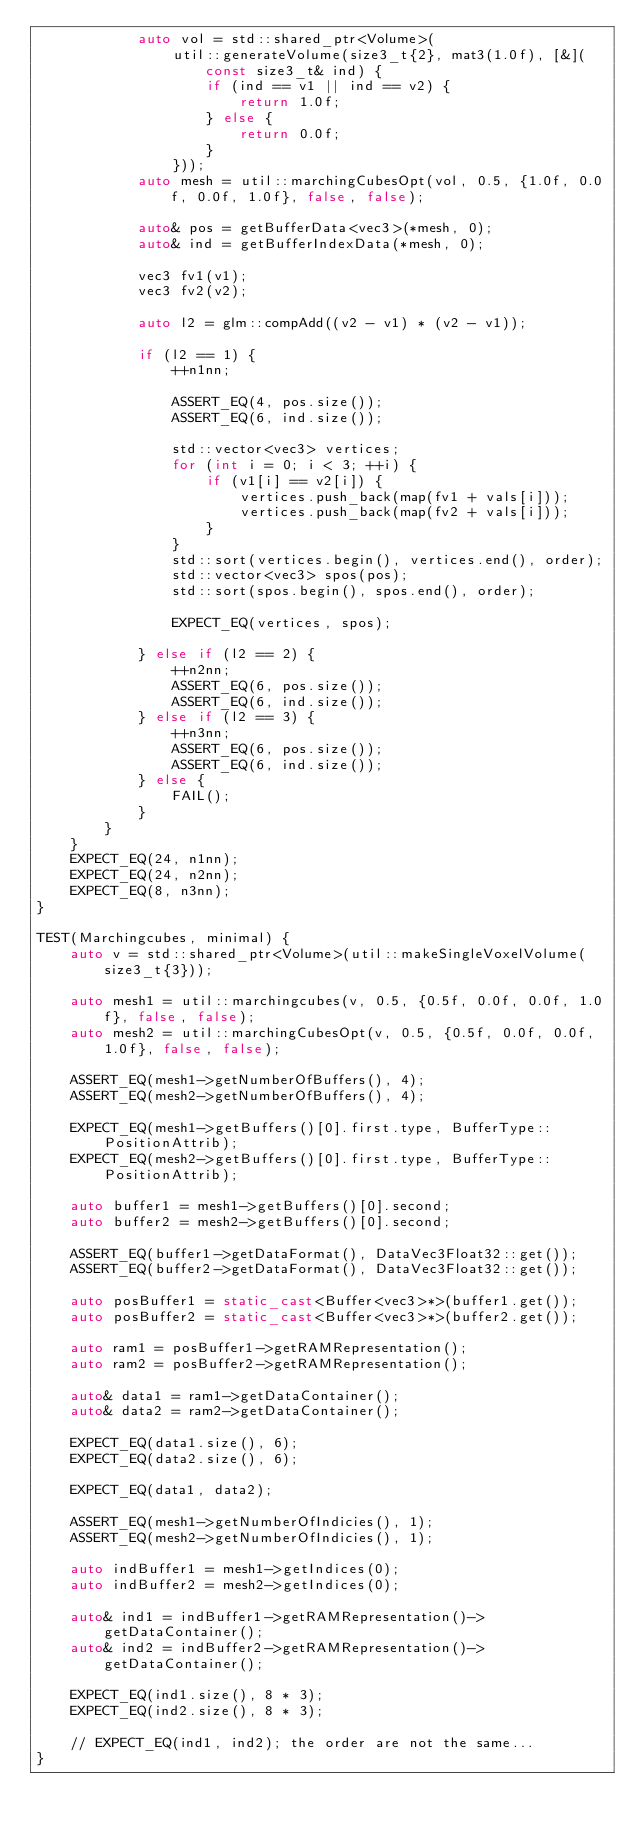Convert code to text. <code><loc_0><loc_0><loc_500><loc_500><_C++_>            auto vol = std::shared_ptr<Volume>(
                util::generateVolume(size3_t{2}, mat3(1.0f), [&](const size3_t& ind) {
                    if (ind == v1 || ind == v2) {
                        return 1.0f;
                    } else {
                        return 0.0f;
                    }
                }));
            auto mesh = util::marchingCubesOpt(vol, 0.5, {1.0f, 0.0f, 0.0f, 1.0f}, false, false);

            auto& pos = getBufferData<vec3>(*mesh, 0);
            auto& ind = getBufferIndexData(*mesh, 0);

            vec3 fv1(v1);
            vec3 fv2(v2);

            auto l2 = glm::compAdd((v2 - v1) * (v2 - v1));

            if (l2 == 1) {
                ++n1nn;

                ASSERT_EQ(4, pos.size());
                ASSERT_EQ(6, ind.size());

                std::vector<vec3> vertices;
                for (int i = 0; i < 3; ++i) {
                    if (v1[i] == v2[i]) {
                        vertices.push_back(map(fv1 + vals[i]));
                        vertices.push_back(map(fv2 + vals[i]));
                    }
                }
                std::sort(vertices.begin(), vertices.end(), order);
                std::vector<vec3> spos(pos);
                std::sort(spos.begin(), spos.end(), order);

                EXPECT_EQ(vertices, spos);

            } else if (l2 == 2) {
                ++n2nn;
                ASSERT_EQ(6, pos.size());
                ASSERT_EQ(6, ind.size());
            } else if (l2 == 3) {
                ++n3nn;
                ASSERT_EQ(6, pos.size());
                ASSERT_EQ(6, ind.size());
            } else {
                FAIL();
            }
        }
    }
    EXPECT_EQ(24, n1nn);
    EXPECT_EQ(24, n2nn);
    EXPECT_EQ(8, n3nn);
}

TEST(Marchingcubes, minimal) {
    auto v = std::shared_ptr<Volume>(util::makeSingleVoxelVolume(size3_t{3}));

    auto mesh1 = util::marchingcubes(v, 0.5, {0.5f, 0.0f, 0.0f, 1.0f}, false, false);
    auto mesh2 = util::marchingCubesOpt(v, 0.5, {0.5f, 0.0f, 0.0f, 1.0f}, false, false);

    ASSERT_EQ(mesh1->getNumberOfBuffers(), 4);
    ASSERT_EQ(mesh2->getNumberOfBuffers(), 4);

    EXPECT_EQ(mesh1->getBuffers()[0].first.type, BufferType::PositionAttrib);
    EXPECT_EQ(mesh2->getBuffers()[0].first.type, BufferType::PositionAttrib);

    auto buffer1 = mesh1->getBuffers()[0].second;
    auto buffer2 = mesh2->getBuffers()[0].second;

    ASSERT_EQ(buffer1->getDataFormat(), DataVec3Float32::get());
    ASSERT_EQ(buffer2->getDataFormat(), DataVec3Float32::get());

    auto posBuffer1 = static_cast<Buffer<vec3>*>(buffer1.get());
    auto posBuffer2 = static_cast<Buffer<vec3>*>(buffer2.get());

    auto ram1 = posBuffer1->getRAMRepresentation();
    auto ram2 = posBuffer2->getRAMRepresentation();

    auto& data1 = ram1->getDataContainer();
    auto& data2 = ram2->getDataContainer();

    EXPECT_EQ(data1.size(), 6);
    EXPECT_EQ(data2.size(), 6);

    EXPECT_EQ(data1, data2);

    ASSERT_EQ(mesh1->getNumberOfIndicies(), 1);
    ASSERT_EQ(mesh2->getNumberOfIndicies(), 1);

    auto indBuffer1 = mesh1->getIndices(0);
    auto indBuffer2 = mesh2->getIndices(0);

    auto& ind1 = indBuffer1->getRAMRepresentation()->getDataContainer();
    auto& ind2 = indBuffer2->getRAMRepresentation()->getDataContainer();

    EXPECT_EQ(ind1.size(), 8 * 3);
    EXPECT_EQ(ind2.size(), 8 * 3);

    // EXPECT_EQ(ind1, ind2); the order are not the same...
}
</code> 